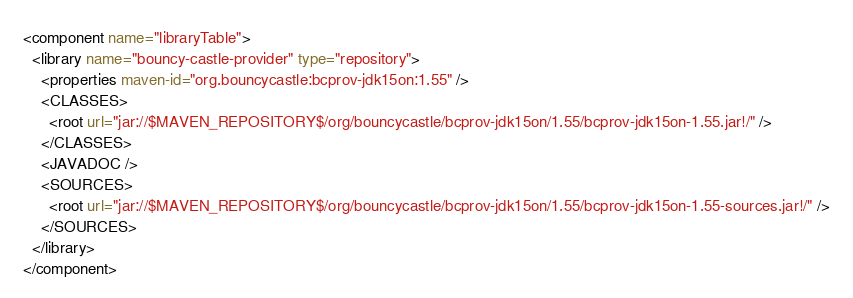Convert code to text. <code><loc_0><loc_0><loc_500><loc_500><_XML_><component name="libraryTable">
  <library name="bouncy-castle-provider" type="repository">
    <properties maven-id="org.bouncycastle:bcprov-jdk15on:1.55" />
    <CLASSES>
      <root url="jar://$MAVEN_REPOSITORY$/org/bouncycastle/bcprov-jdk15on/1.55/bcprov-jdk15on-1.55.jar!/" />
    </CLASSES>
    <JAVADOC />
    <SOURCES>
      <root url="jar://$MAVEN_REPOSITORY$/org/bouncycastle/bcprov-jdk15on/1.55/bcprov-jdk15on-1.55-sources.jar!/" />
    </SOURCES>
  </library>
</component></code> 